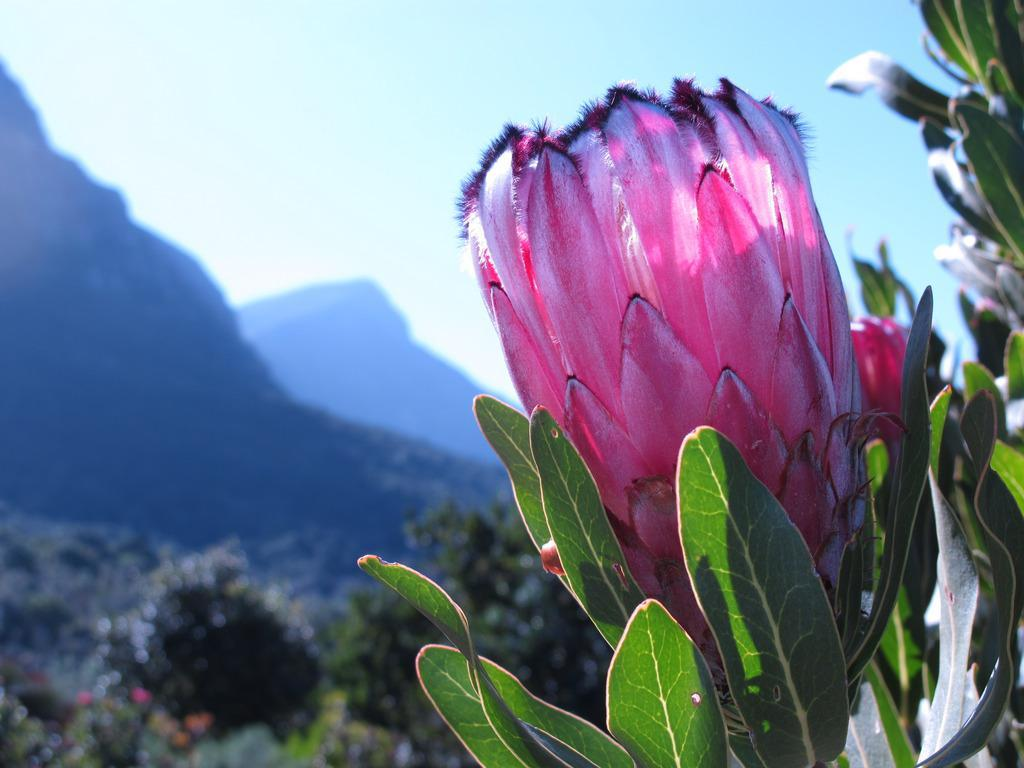What is the main subject of the image? There is a flower in the image. Where is the flower located? The flower is on a plant. What can be seen in the background of the image? There are trees, hills, and the sky visible in the background of the image. What type of ice can be seen melting on the flower in the image? There is no ice present in the image, and therefore no ice can be seen melting on the flower. 